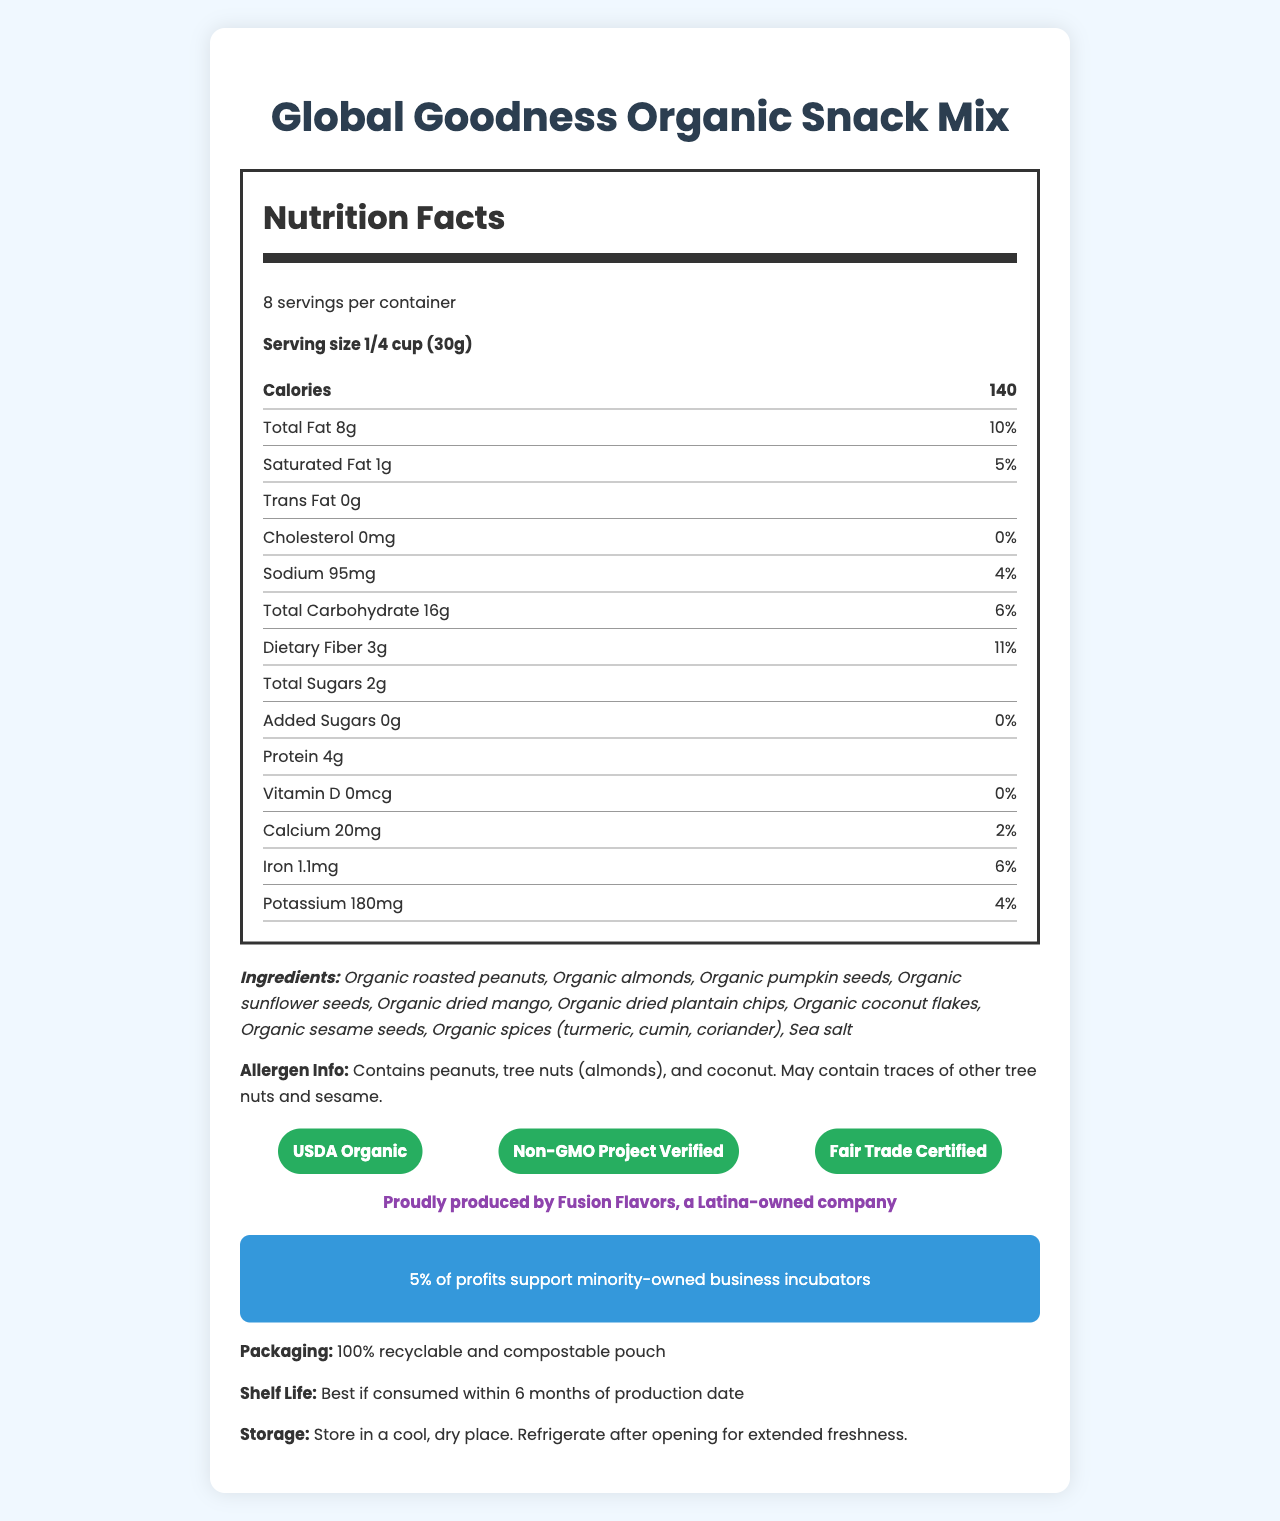what is the serving size of the Global Goodness Organic Snack Mix? The serving size is stated clearly next to the nutritional facts header and specifies both volume and weight: 1/4 cup (30g).
Answer: 1/4 cup (30g) how many servings are in one container? The number of servings per container is stated in the document: 8 servings per container.
Answer: 8 what is the amount of sodium per serving? The amount of sodium per serving is specified within the nutrition facts as 95mg.
Answer: 95mg what are the top three ingredients listed in the Global Goodness Organic Snack Mix? The top three ingredients are listed first in the ingredients section.
Answer: Organic roasted peanuts, Organic almonds, Organic pumpkin seeds what certifications does the Global Goodness Organic Snack Mix have? The certifications are listed in the document, and their badges are displayed prominently.
Answer: USDA Organic, Non-GMO Project Verified, Fair Trade Certified how many calories does a serving of Global Goodness Organic Snack Mix contain? The number of calories per serving is clearly mentioned in the nutrition facts as 140.
Answer: 140 how much protein is in each serving? The amount of protein per serving is stated in the nutrition facts as 4g.
Answer: 4g which nutrient has the highest daily value percentage in one serving? A. Saturated Fat B. Dietary Fiber C. Iron D. Sodium Dietary Fiber has the highest daily value percentage at 11%, as stated in the nutrition facts.
Answer: Dietary Fiber which of the following is an allergen present in the Global Goodness Organic Snack Mix? i. Gluten ii. Soy iii. Coconut The allergen information in the document specifically mentions coconut as an allergen.
Answer: iii. Coconut is the Global Goodness Organic Snack Mix produced by a minority-owned business? The document indicates that it is proudly produced by Fusion Flavors, a Latina-owned company.
Answer: Yes does this product contain any added sugars? The nutrition facts specify that the amount of added sugars per serving is 0g, meaning there are no added sugars.
Answer: No describe the social impact associated with the Global Goodness Organic Snack Mix. The document clearly states that 5% of profits are allocated to supporting minority-owned business incubators.
Answer: 5% of profits support minority-owned business incubators how long is the shelf life of the Global Goodness Organic Snack Mix? The shelf life information specifies that it is best if consumed within 6 months of its production date.
Answer: Best if consumed within 6 months of production date what are the storage instructions for this product? The storage instructions advise to keep the product in a cool, dry place and to refrigerate after opening.
Answer: Store in a cool, dry place. Refrigerate after opening for extended freshness. which ingredient is not listed in the Global Goodness Organic Snack Mix? A. Organic sesame seeds B. Organic sunflower seeds C. Organic cashews D. Organic dried mango The listed ingredients include organic sesame seeds, organic sunflower seeds, and organic dried mango, but do not mention organic cashews.
Answer: C. Organic cashews what is the daily value percentage of iron in one serving? The daily value percentage of iron per serving is specified as 6% in the nutrition facts.
Answer: 6% what is the purpose of the ingredients in relation to cultural diversity? The document does not provide specific information on how the ingredients relate to cultural diversity.
Answer: Not enough information 